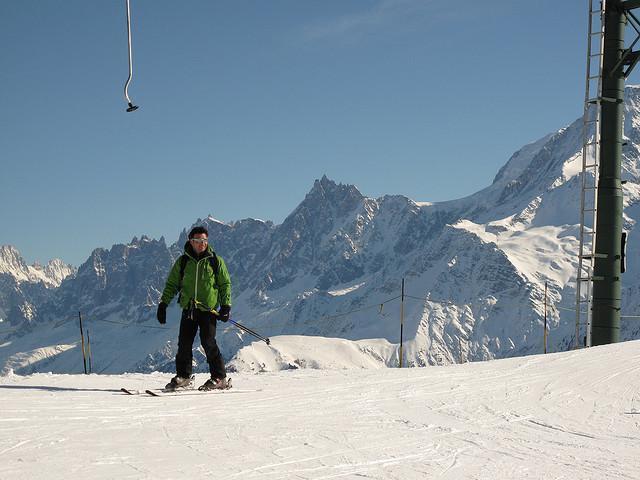How many people are wearing black pants?
Give a very brief answer. 1. 